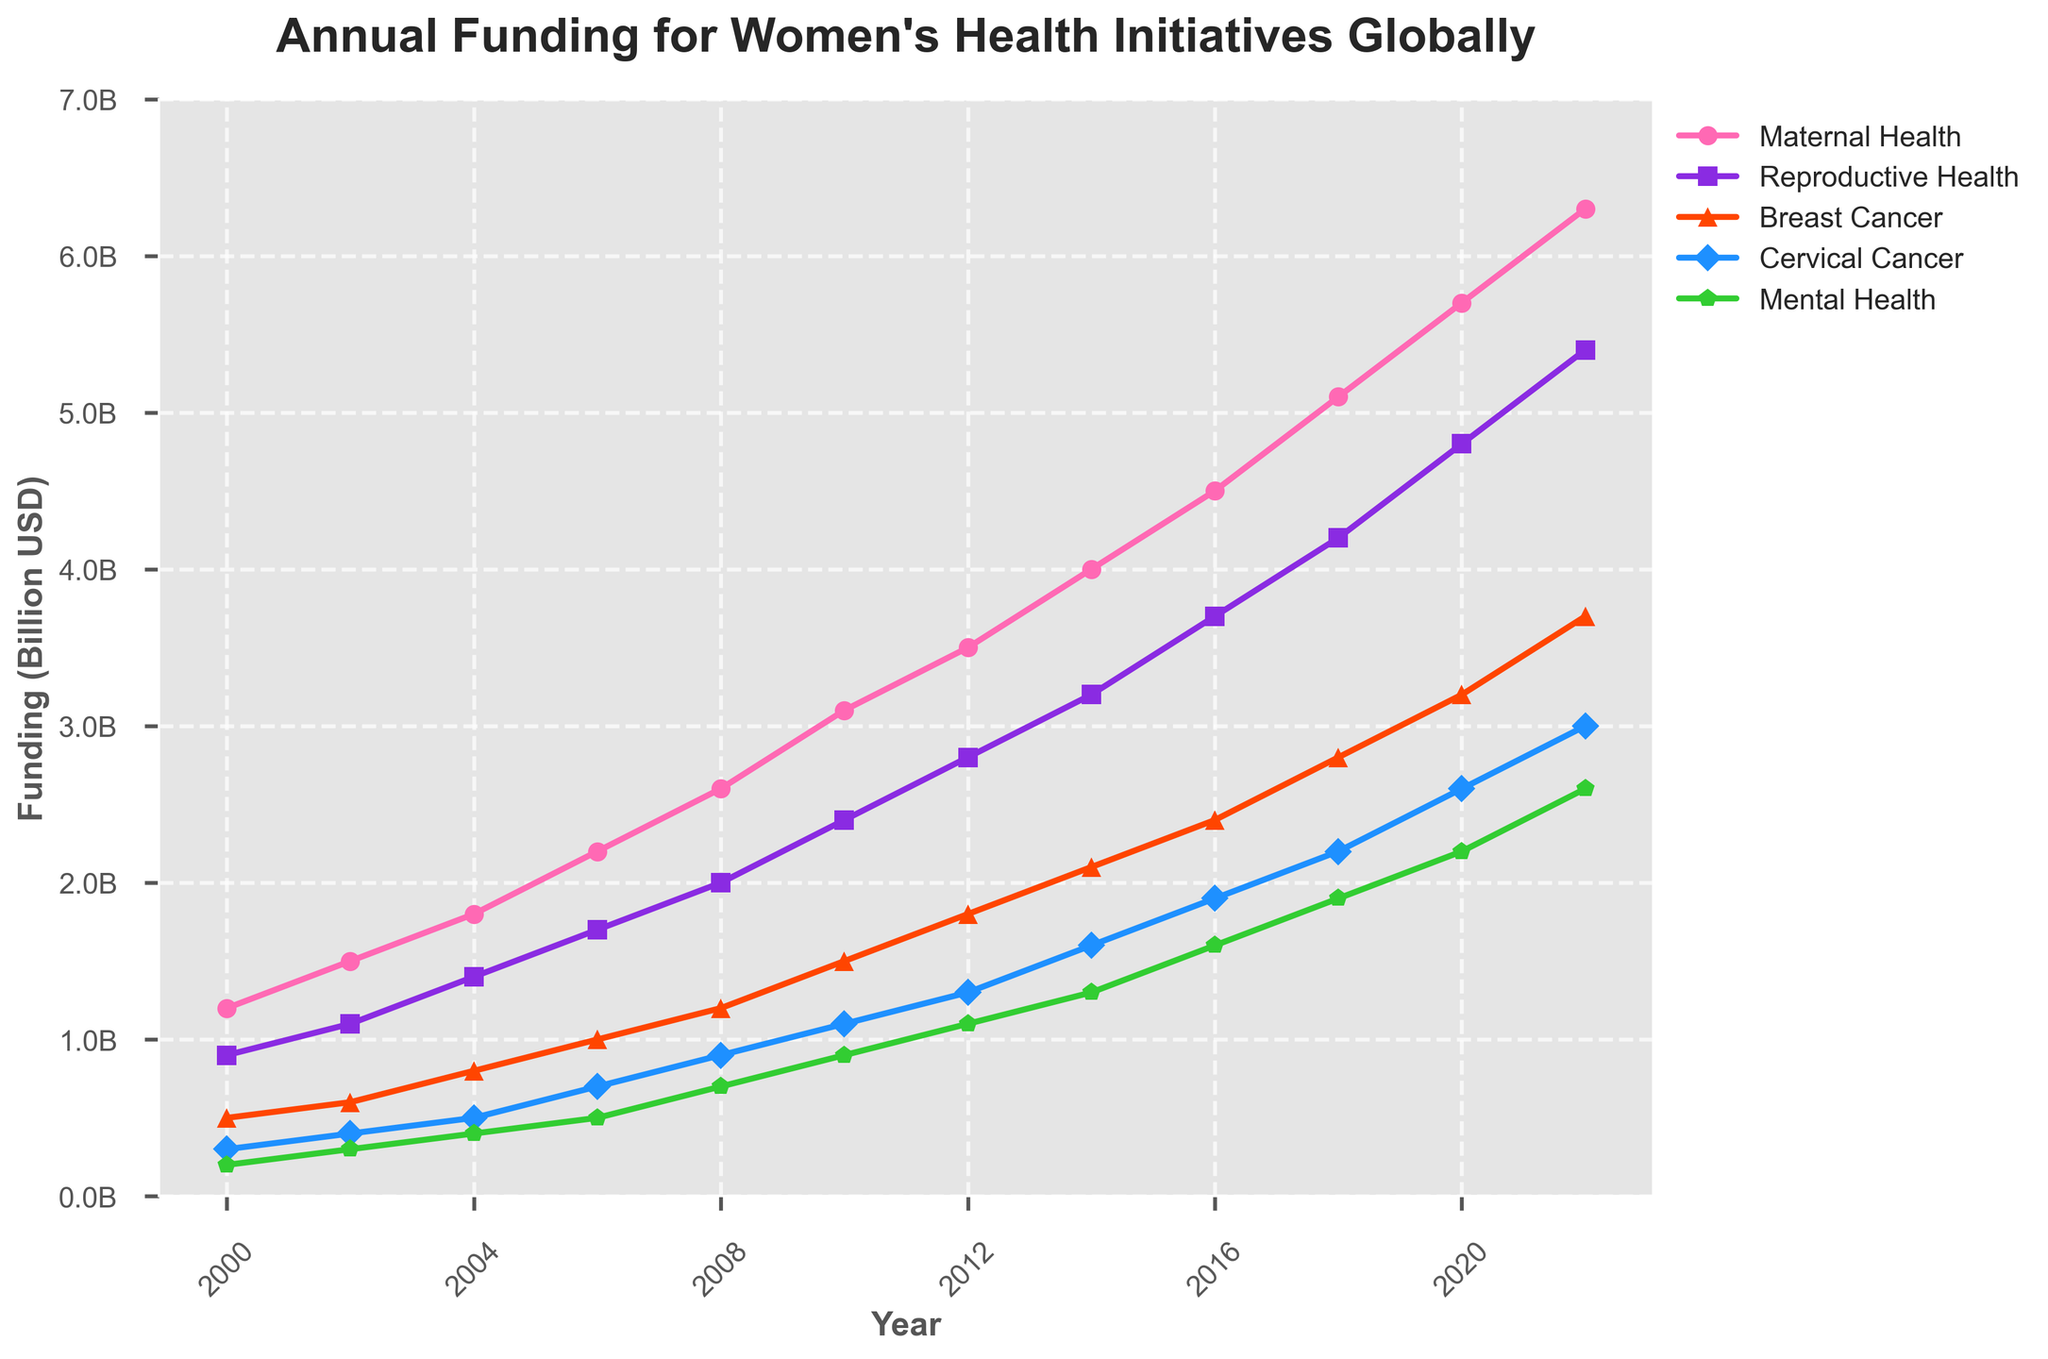What is the trend of funding for Maternal Health from 2000 to 2022? Start from the data point in 2000 where the funding is 1.2 billion USD, observe the plot to see how it increases gradually each year, reaching 6.3 billion USD in 2022.
Answer: Increasing trend How does the funding for Breast Cancer in 2022 compare to 2000? In 2000, the funding for Breast Cancer was 0.5 billion USD. By 2022, it increased to 3.7 billion USD, showing a substantial increase.
Answer: Increased Which health category received the highest funding in 2010? Look at the data points for 2010: Maternal Health (3.1B), Reproductive Health (2.4B), Breast Cancer (1.5B), Cervical Cancer (1.1B), Mental Health (0.9B). The highest is Maternal Health.
Answer: Maternal Health What is the difference in funding for Mental Health between 2004 and 2018? In 2004, the funding for Mental Health was 0.4 billion USD, and in 2018, it was 1.9 billion USD. The difference is 1.9B - 0.4B = 1.5 billion USD.
Answer: 1.5 billion USD What is the average funding for Reproductive Health over the years provided (2000-2022)? Sum the funding for Reproductive Health over all years and divide by the number of years. Sum = 0.9 + 1.1 + 1.4 + 1.7 + 2.0 + 2.4 + 2.8 + 3.2 + 3.7 + 4.2 + 4.8 + 5.4 = 35.6; there are 12 years. Average = 35.6 / 12 ≈ 2.97 billion USD.
Answer: 2.97 billion USD Which year saw the largest increase in funding for Cervical Cancer compared to the previous year? Compare the yearly increments for Cervical Cancer. The increases are 0.1, 0.1, 0.2, 0.2, 0.2, 0.1, 0.2, 0.3, 0.3, 0.4, 0.4. The largest increase is between 2008 and 2010 (0.2 billion USD).
Answer: 2008 to 2010 How does the funding for Maternal Health in 2016 compare to Reproductive Health in 2012? Maternal Health in 2016 saw a funding of 4.5 billion USD while Reproductive Health in 2012 had a funding of 2.8 billion USD. Maternal Health funding is significantly higher.
Answer: Maternal Health is higher Which health category had the least funding in 2022? Checking the data for 2022: Maternal Health (6.3B), Reproductive Health (5.4B), Breast Cancer (3.7B), Cervical Cancer (3.0B), Mental Health (2.6B). The lowest is Mental Health.
Answer: Mental Health What was the total funding allocated across all health categories in 2018? Add the funding for each category in 2018: 5.1 (Maternal Health) + 4.2 (Reproductive Health) + 2.8 (Breast Cancer) + 2.2 (Cervical Cancer) + 1.9 (Mental Health) = 16.2 billion USD.
Answer: 16.2 billion USD 